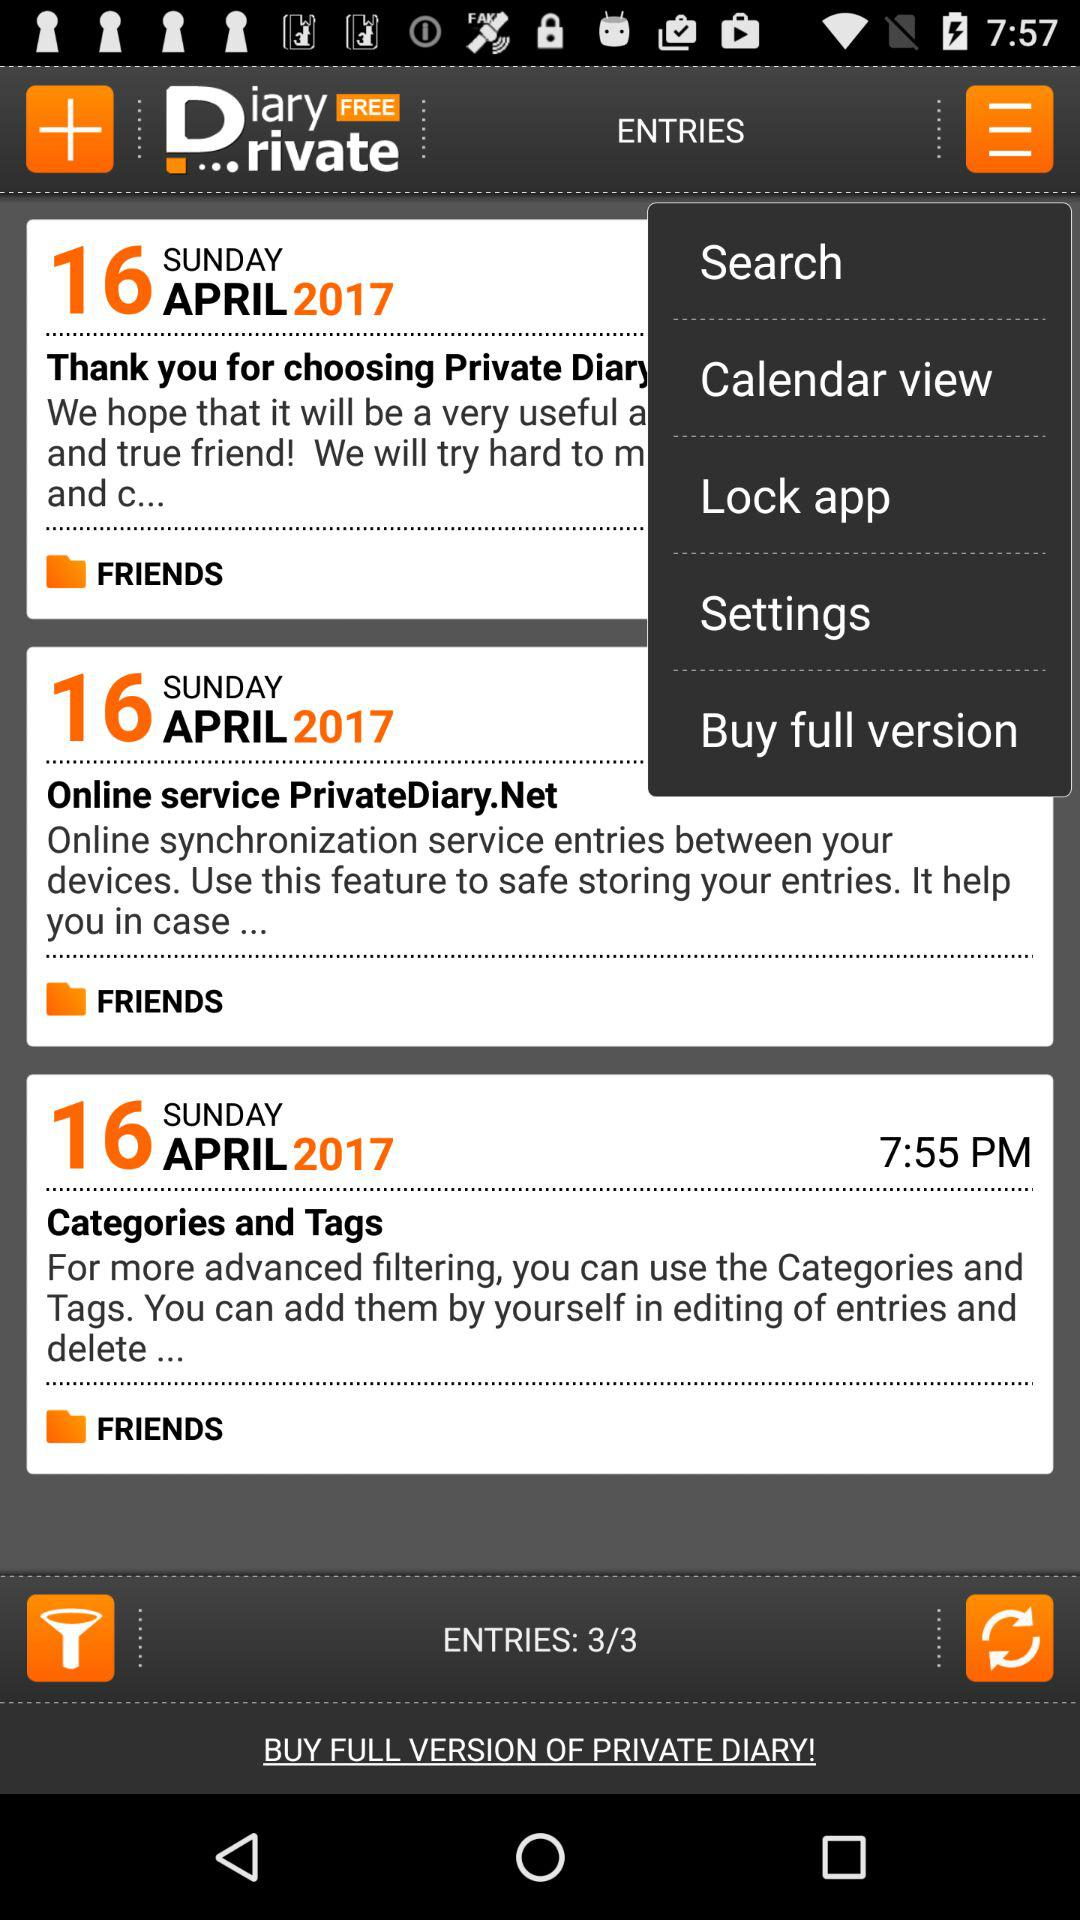What is the name of the application? The name of the application is "Private DIARY Free - Personal". 